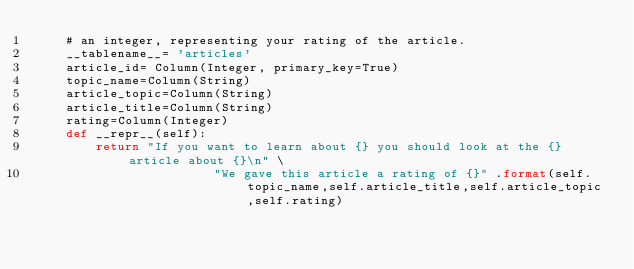<code> <loc_0><loc_0><loc_500><loc_500><_Python_>	# an integer, representing your rating of the article.
	__tablename__= 'articles'
	article_id= Column(Integer, primary_key=True)
	topic_name=Column(String)
	article_topic=Column(String)
	article_title=Column(String)
	rating=Column(Integer)
	def __repr__(self):
		return "If you want to learn about {} you should look at the {} article about {}\n" \
						"We gave this article a rating of {}" .format(self.topic_name,self.article_title,self.article_topic,self.rating)


</code> 